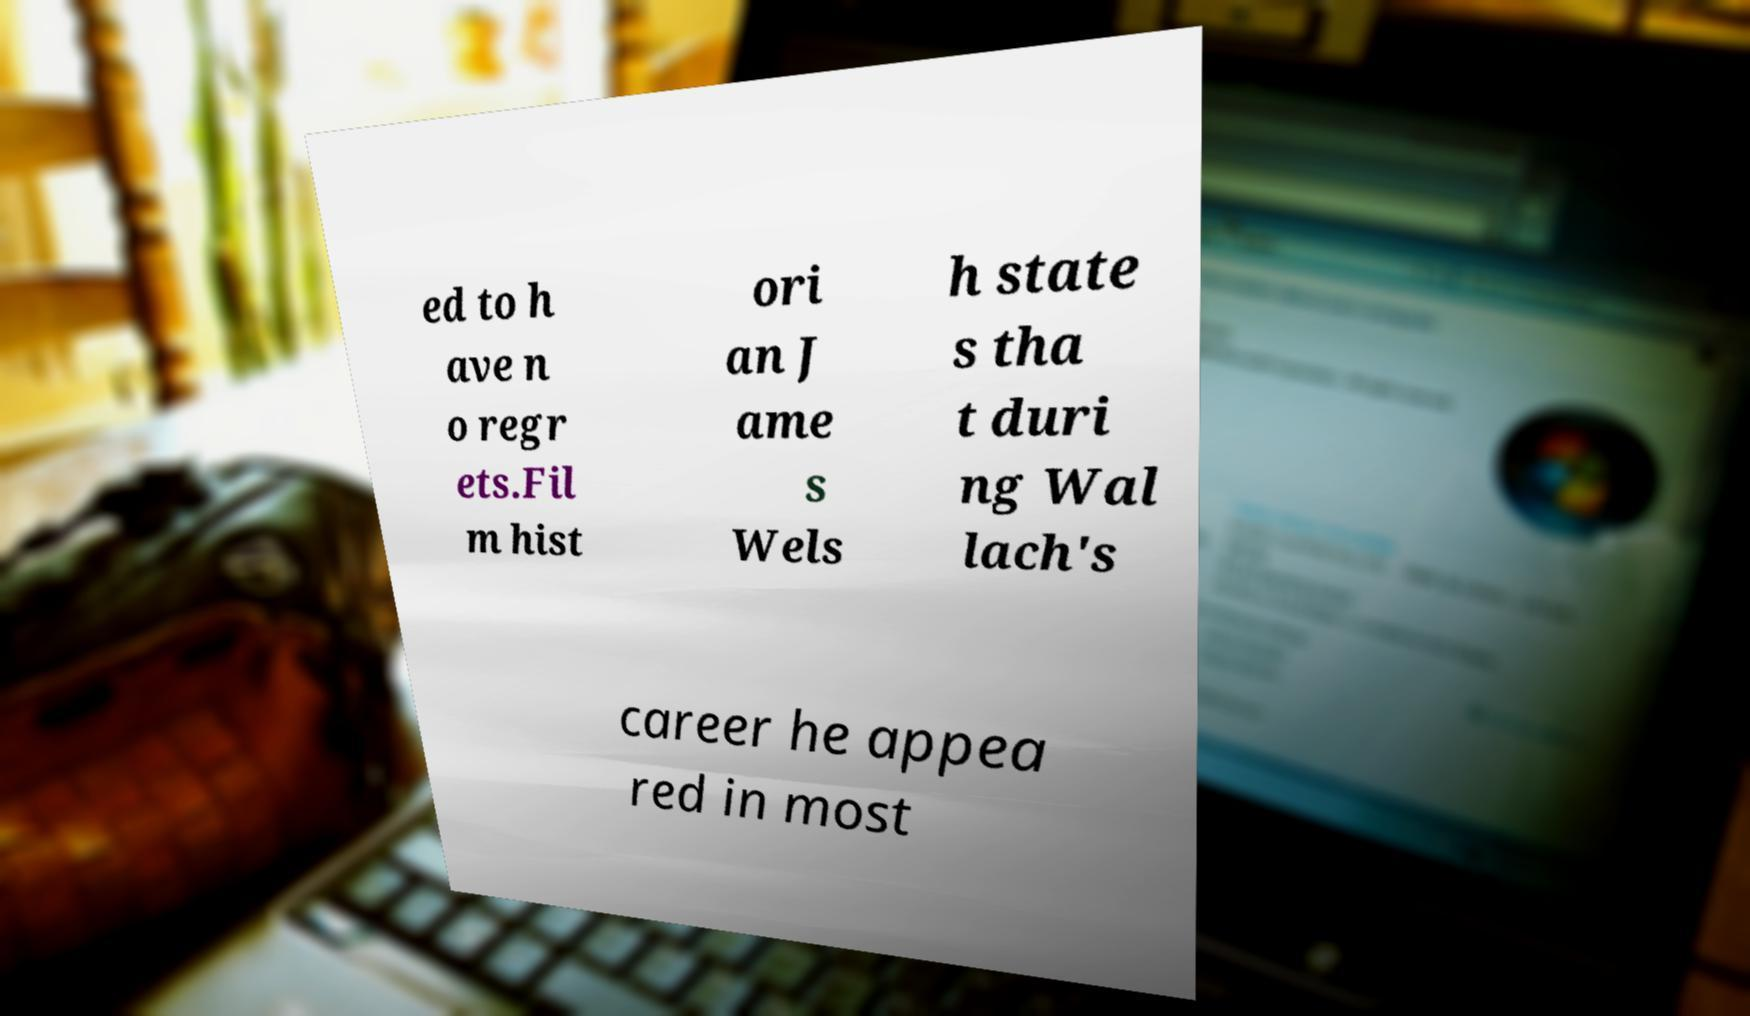Could you extract and type out the text from this image? ed to h ave n o regr ets.Fil m hist ori an J ame s Wels h state s tha t duri ng Wal lach's career he appea red in most 